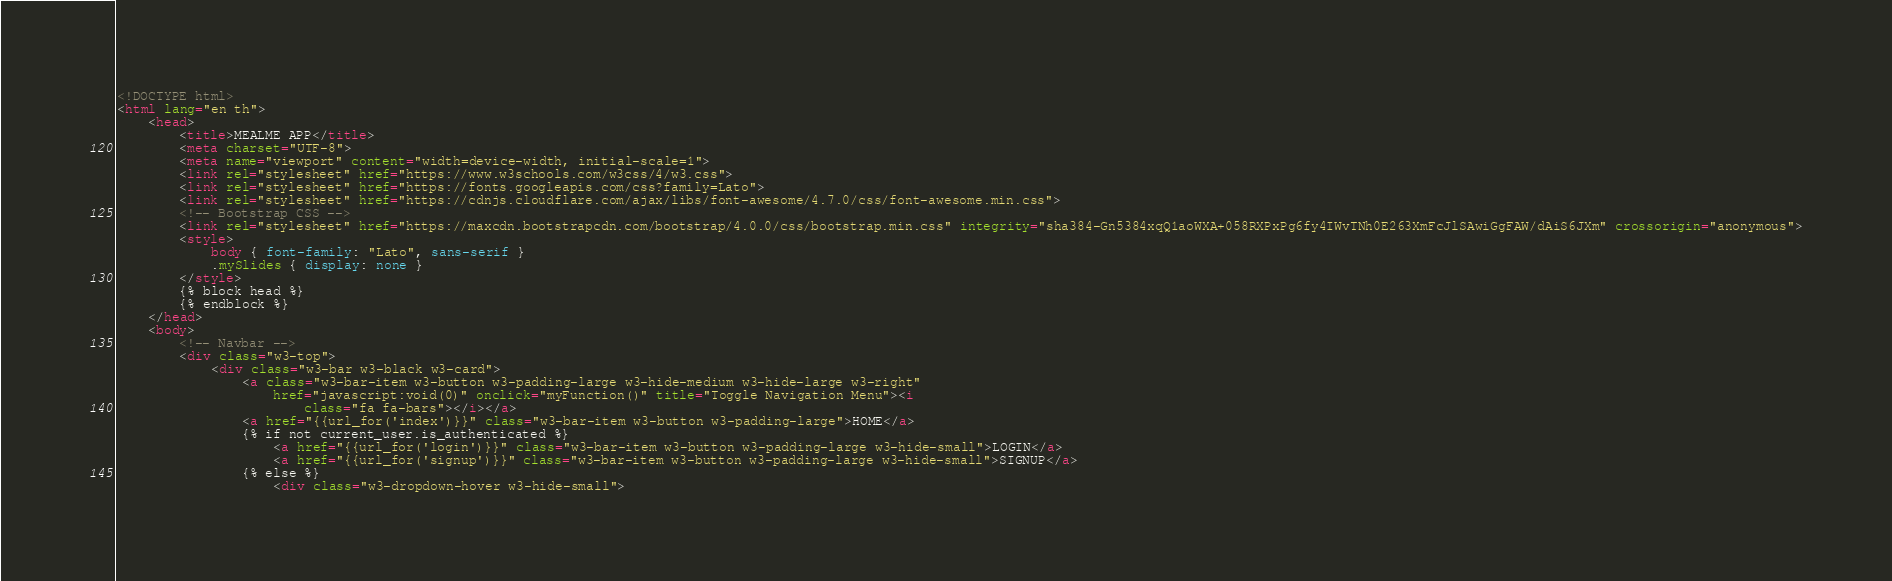Convert code to text. <code><loc_0><loc_0><loc_500><loc_500><_HTML_><!DOCTYPE html>
<html lang="en th">
    <head>
        <title>MEALME APP</title>
        <meta charset="UTF-8">
        <meta name="viewport" content="width=device-width, initial-scale=1">
        <link rel="stylesheet" href="https://www.w3schools.com/w3css/4/w3.css">
        <link rel="stylesheet" href="https://fonts.googleapis.com/css?family=Lato">
        <link rel="stylesheet" href="https://cdnjs.cloudflare.com/ajax/libs/font-awesome/4.7.0/css/font-awesome.min.css">
        <!-- Bootstrap CSS -->
        <link rel="stylesheet" href="https://maxcdn.bootstrapcdn.com/bootstrap/4.0.0/css/bootstrap.min.css" integrity="sha384-Gn5384xqQ1aoWXA+058RXPxPg6fy4IWvTNh0E263XmFcJlSAwiGgFAW/dAiS6JXm" crossorigin="anonymous">
        <style>
            body { font-family: "Lato", sans-serif }
            .mySlides { display: none }
        </style>
        {% block head %}
        {% endblock %}
    </head>
    <body>
        <!-- Navbar -->
        <div class="w3-top">
            <div class="w3-bar w3-black w3-card">
                <a class="w3-bar-item w3-button w3-padding-large w3-hide-medium w3-hide-large w3-right"
                    href="javascript:void(0)" onclick="myFunction()" title="Toggle Navigation Menu"><i
                        class="fa fa-bars"></i></a>
                <a href="{{url_for('index')}}" class="w3-bar-item w3-button w3-padding-large">HOME</a>        
                {% if not current_user.is_authenticated %}        
                    <a href="{{url_for('login')}}" class="w3-bar-item w3-button w3-padding-large w3-hide-small">LOGIN</a>
                    <a href="{{url_for('signup')}}" class="w3-bar-item w3-button w3-padding-large w3-hide-small">SIGNUP</a>
                {% else %}
                    <div class="w3-dropdown-hover w3-hide-small"></code> 